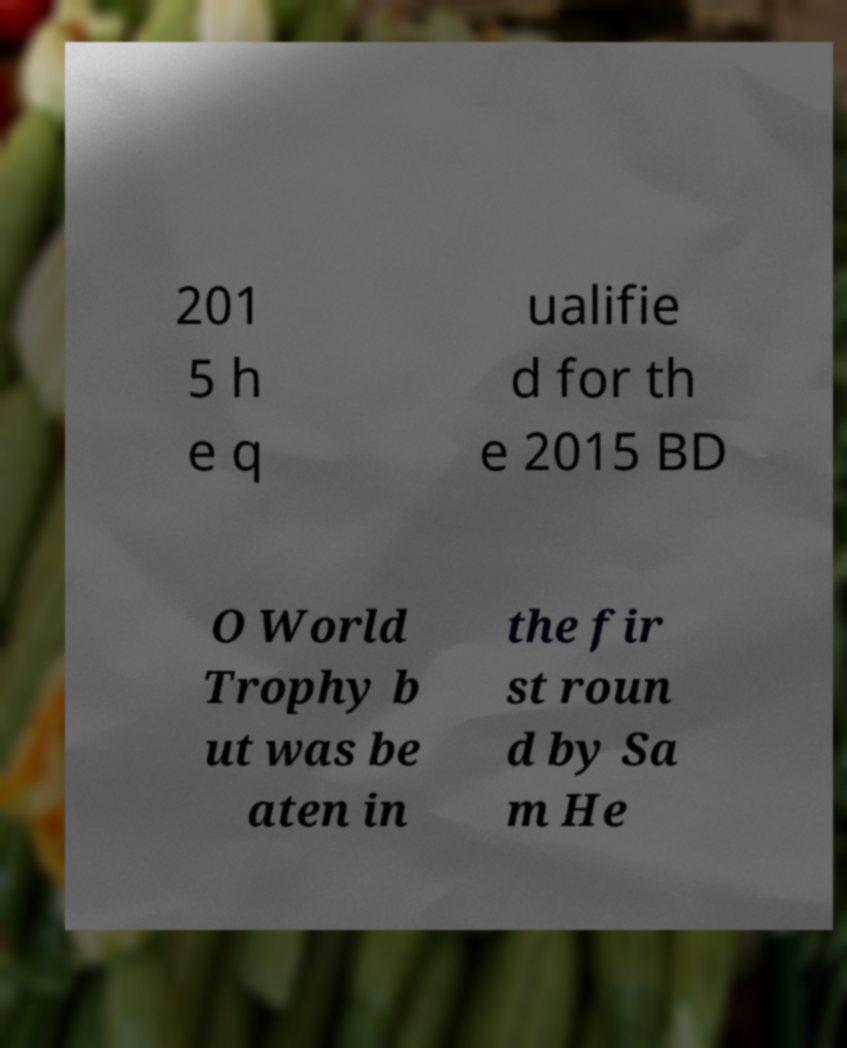I need the written content from this picture converted into text. Can you do that? 201 5 h e q ualifie d for th e 2015 BD O World Trophy b ut was be aten in the fir st roun d by Sa m He 